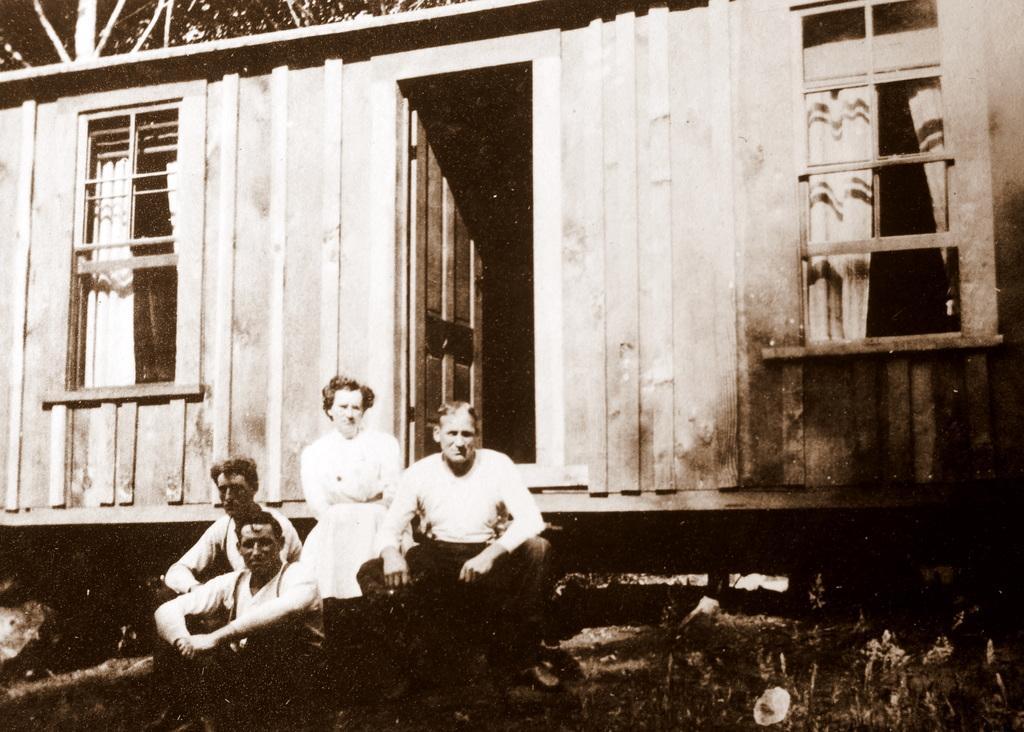Describe this image in one or two sentences. It is the black and white image in which there are four persons sitting on the steps. In the background there is a wooden house with a door. On the right side there are windows. At the bottom there is grass. 